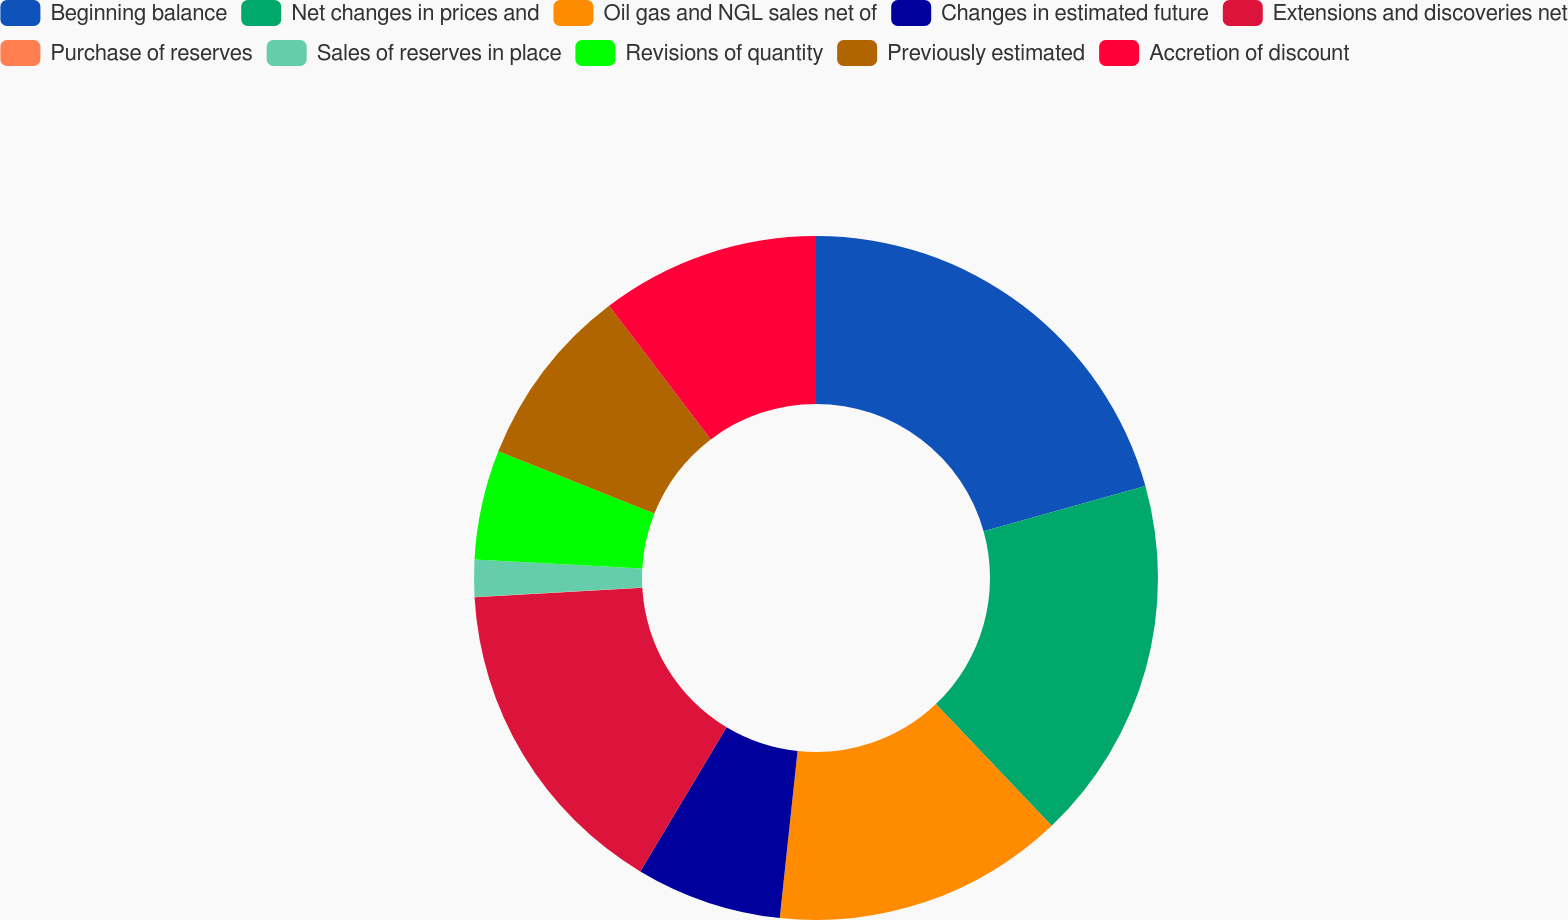Convert chart to OTSL. <chart><loc_0><loc_0><loc_500><loc_500><pie_chart><fcel>Beginning balance<fcel>Net changes in prices and<fcel>Oil gas and NGL sales net of<fcel>Changes in estimated future<fcel>Extensions and discoveries net<fcel>Purchase of reserves<fcel>Sales of reserves in place<fcel>Revisions of quantity<fcel>Previously estimated<fcel>Accretion of discount<nl><fcel>20.67%<fcel>17.23%<fcel>13.79%<fcel>6.9%<fcel>15.51%<fcel>0.02%<fcel>1.74%<fcel>5.18%<fcel>8.62%<fcel>10.34%<nl></chart> 